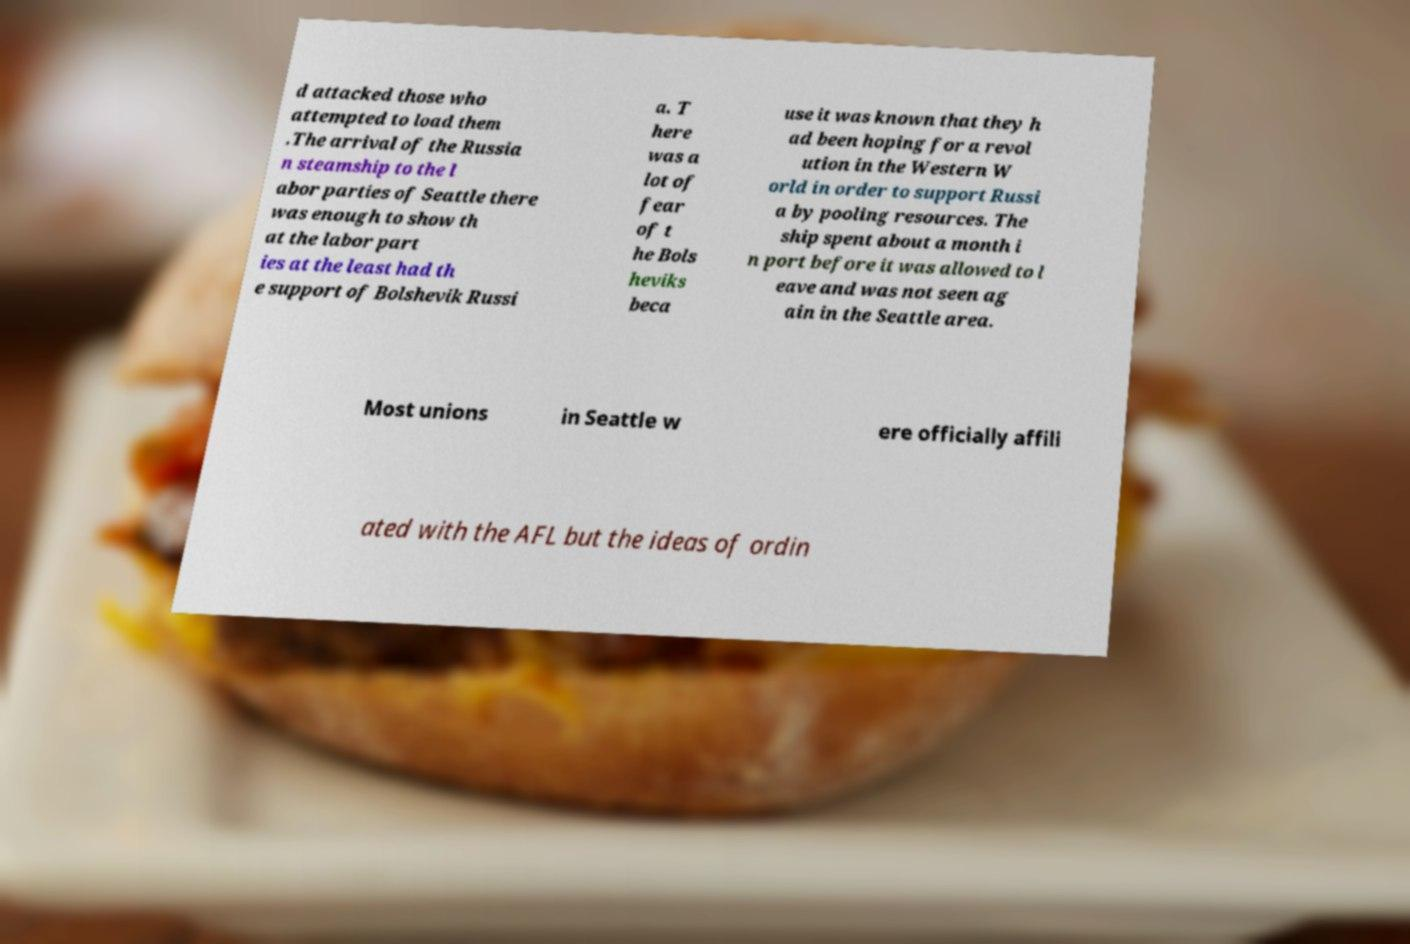Please read and relay the text visible in this image. What does it say? d attacked those who attempted to load them .The arrival of the Russia n steamship to the l abor parties of Seattle there was enough to show th at the labor part ies at the least had th e support of Bolshevik Russi a. T here was a lot of fear of t he Bols heviks beca use it was known that they h ad been hoping for a revol ution in the Western W orld in order to support Russi a by pooling resources. The ship spent about a month i n port before it was allowed to l eave and was not seen ag ain in the Seattle area. Most unions in Seattle w ere officially affili ated with the AFL but the ideas of ordin 